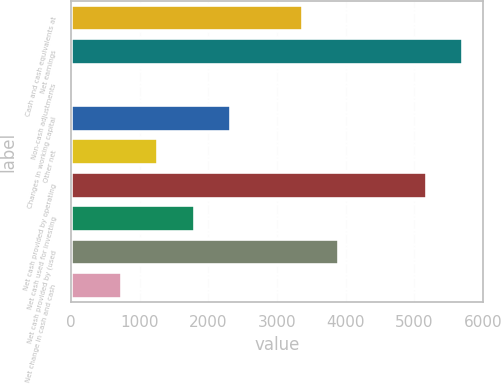Convert chart to OTSL. <chart><loc_0><loc_0><loc_500><loc_500><bar_chart><fcel>Cash and cash equivalents at<fcel>Net earnings<fcel>Non-cash adjustments<fcel>Changes in working capital<fcel>Other net<fcel>Net cash provided by operating<fcel>Net cash used for investing<fcel>Net cash provided by (used<fcel>Net change in cash and cash<nl><fcel>3380.5<fcel>5715.7<fcel>35<fcel>2327.1<fcel>1273.7<fcel>5189<fcel>1800.4<fcel>3907.2<fcel>747<nl></chart> 